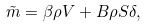Convert formula to latex. <formula><loc_0><loc_0><loc_500><loc_500>\tilde { m } = \beta \rho V + B \rho S \delta ,</formula> 